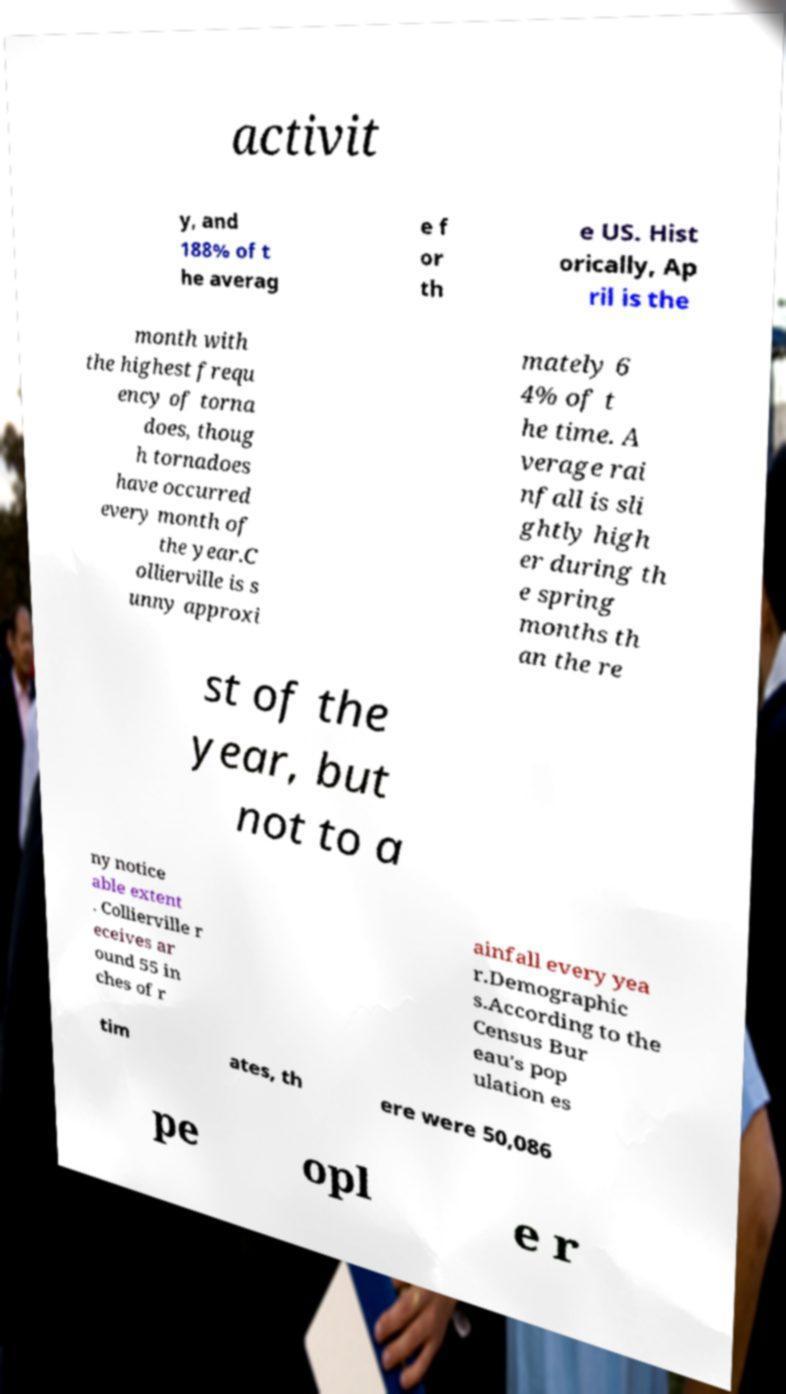Please read and relay the text visible in this image. What does it say? activit y, and 188% of t he averag e f or th e US. Hist orically, Ap ril is the month with the highest frequ ency of torna does, thoug h tornadoes have occurred every month of the year.C ollierville is s unny approxi mately 6 4% of t he time. A verage rai nfall is sli ghtly high er during th e spring months th an the re st of the year, but not to a ny notice able extent . Collierville r eceives ar ound 55 in ches of r ainfall every yea r.Demographic s.According to the Census Bur eau's pop ulation es tim ates, th ere were 50,086 pe opl e r 